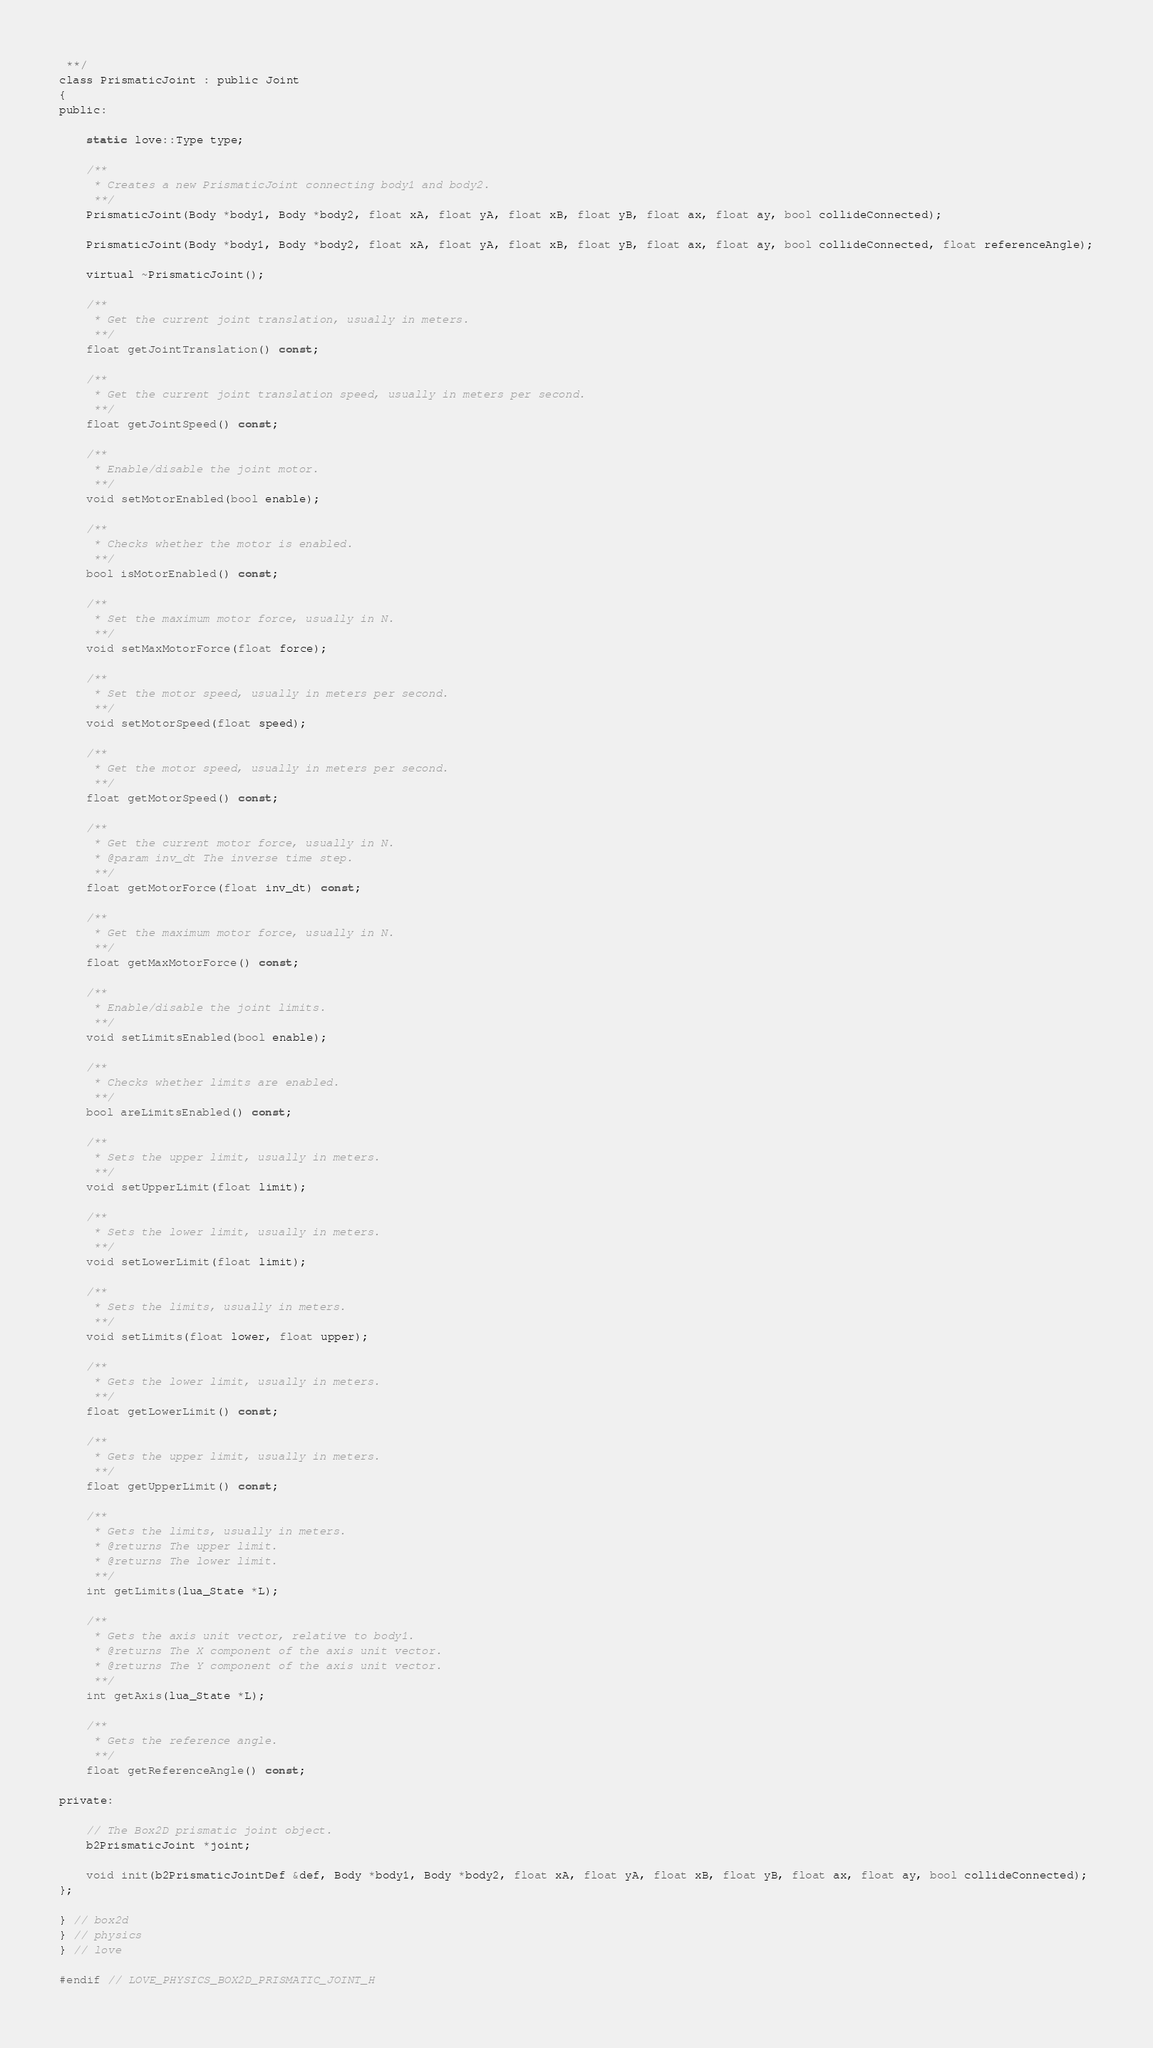Convert code to text. <code><loc_0><loc_0><loc_500><loc_500><_C_> **/
class PrismaticJoint : public Joint
{
public:

	static love::Type type;

	/**
	 * Creates a new PrismaticJoint connecting body1 and body2.
	 **/
	PrismaticJoint(Body *body1, Body *body2, float xA, float yA, float xB, float yB, float ax, float ay, bool collideConnected);

	PrismaticJoint(Body *body1, Body *body2, float xA, float yA, float xB, float yB, float ax, float ay, bool collideConnected, float referenceAngle);

	virtual ~PrismaticJoint();

	/**
	 * Get the current joint translation, usually in meters.
	 **/
	float getJointTranslation() const;

	/**
	 * Get the current joint translation speed, usually in meters per second.
	 **/
	float getJointSpeed() const;

	/**
	 * Enable/disable the joint motor.
	 **/
	void setMotorEnabled(bool enable);

	/**
	 * Checks whether the motor is enabled.
	 **/
	bool isMotorEnabled() const;

	/**
	 * Set the maximum motor force, usually in N.
	 **/
	void setMaxMotorForce(float force);

	/**
	 * Set the motor speed, usually in meters per second.
	 **/
	void setMotorSpeed(float speed);

	/**
	 * Get the motor speed, usually in meters per second.
	 **/
	float getMotorSpeed() const;

	/**
	 * Get the current motor force, usually in N.
	 * @param inv_dt The inverse time step.
	 **/
	float getMotorForce(float inv_dt) const;

	/**
	 * Get the maximum motor force, usually in N.
	 **/
	float getMaxMotorForce() const;

	/**
	 * Enable/disable the joint limits.
	 **/
	void setLimitsEnabled(bool enable);

	/**
	 * Checks whether limits are enabled.
	 **/
	bool areLimitsEnabled() const;

	/**
	 * Sets the upper limit, usually in meters.
	 **/
	void setUpperLimit(float limit);

	/**
	 * Sets the lower limit, usually in meters.
	 **/
	void setLowerLimit(float limit);

	/**
	 * Sets the limits, usually in meters.
	 **/
	void setLimits(float lower, float upper);

	/**
	 * Gets the lower limit, usually in meters.
	 **/
	float getLowerLimit() const;

	/**
	 * Gets the upper limit, usually in meters.
	 **/
	float getUpperLimit() const;

	/**
	 * Gets the limits, usually in meters.
	 * @returns The upper limit.
	 * @returns The lower limit.
	 **/
	int getLimits(lua_State *L);

	/**
	 * Gets the axis unit vector, relative to body1.
	 * @returns The X component of the axis unit vector.
	 * @returns The Y component of the axis unit vector.
	 **/
	int getAxis(lua_State *L);

	/**
	 * Gets the reference angle.
	 **/
	float getReferenceAngle() const;

private:

	// The Box2D prismatic joint object.
	b2PrismaticJoint *joint;

	void init(b2PrismaticJointDef &def, Body *body1, Body *body2, float xA, float yA, float xB, float yB, float ax, float ay, bool collideConnected);
};

} // box2d
} // physics
} // love

#endif // LOVE_PHYSICS_BOX2D_PRISMATIC_JOINT_H
</code> 